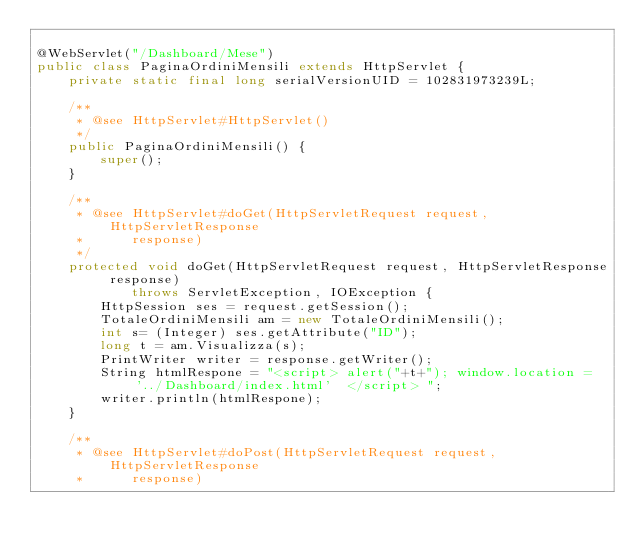<code> <loc_0><loc_0><loc_500><loc_500><_Java_>
@WebServlet("/Dashboard/Mese")
public class PaginaOrdiniMensili extends HttpServlet {
	private static final long serialVersionUID = 102831973239L;
	
	/**
	 * @see HttpServlet#HttpServlet()
	 */
	public PaginaOrdiniMensili() {
		super();
	}

	/**
	 * @see HttpServlet#doGet(HttpServletRequest request, HttpServletResponse
	 *      response)
	 */
	protected void doGet(HttpServletRequest request, HttpServletResponse response)
			throws ServletException, IOException {
		HttpSession ses = request.getSession();
		TotaleOrdiniMensili am = new TotaleOrdiniMensili();
		int s= (Integer) ses.getAttribute("ID");
		long t = am.Visualizza(s);
        PrintWriter writer = response.getWriter();
        String htmlRespone = "<script> alert("+t+"); window.location = '../Dashboard/index.html'  </script> ";
        writer.println(htmlRespone);
	}

	/**
	 * @see HttpServlet#doPost(HttpServletRequest request, HttpServletResponse
	 *      response)</code> 